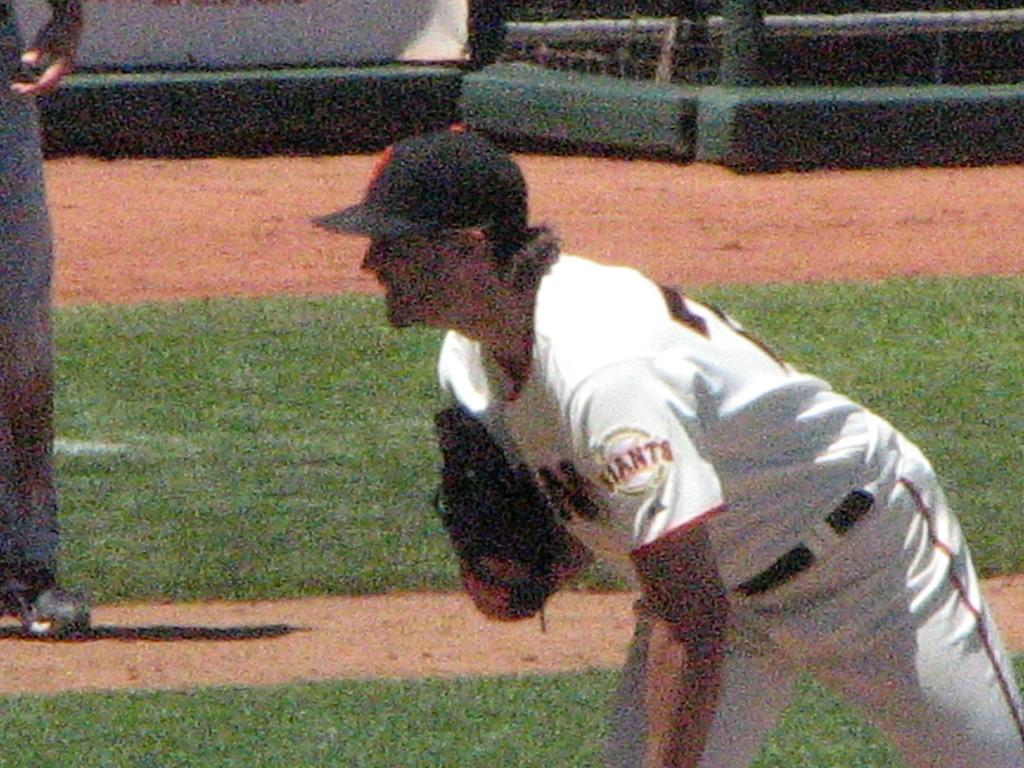<image>
Share a concise interpretation of the image provided. A baseball player from the San Francisco Giants stands on a baseball field. 